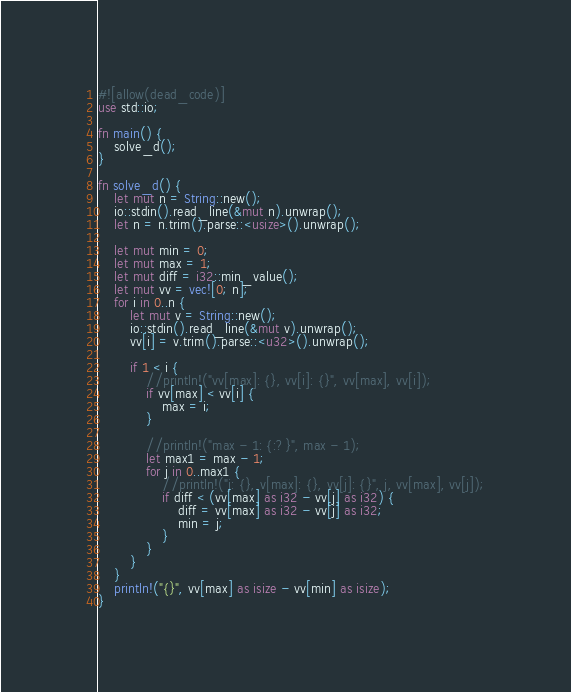Convert code to text. <code><loc_0><loc_0><loc_500><loc_500><_Rust_>#![allow(dead_code)]
use std::io;

fn main() {
    solve_d();
}

fn solve_d() {
    let mut n = String::new();
    io::stdin().read_line(&mut n).unwrap();
    let n = n.trim().parse::<usize>().unwrap();

    let mut min = 0;
    let mut max = 1;
    let mut diff = i32::min_value();
    let mut vv = vec![0; n];
    for i in 0..n {
        let mut v = String::new();
        io::stdin().read_line(&mut v).unwrap();
        vv[i] = v.trim().parse::<u32>().unwrap();

        if 1 < i {
            //println!("vv[max]: {}, vv[i]: {}", vv[max], vv[i]);
            if vv[max] < vv[i] {
                max = i;
            }

            //println!("max - 1: {:?}", max - 1);
            let max1 = max - 1;
            for j in 0..max1 {
                //println!("j: {}, v[max]: {}, vv[j]: {}", j, vv[max], vv[j]);
                if diff < (vv[max] as i32 - vv[j] as i32) {
                    diff = vv[max] as i32 - vv[j] as i32;
                    min = j;
                }
            }
        }
    }
    println!("{}", vv[max] as isize - vv[min] as isize);
}

</code> 